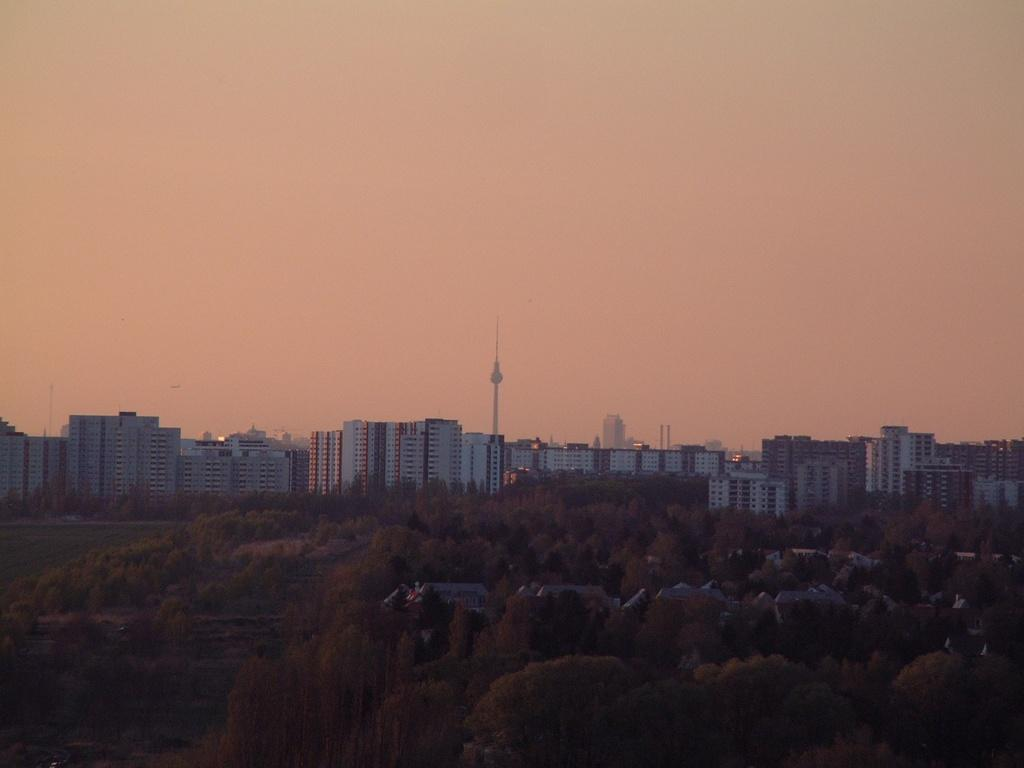What is located at the bottom of the picture? There are trees at the bottom of the picture. What can be seen in the background of the picture? There are trees, buildings, and a tower in the background. What is visible at the top of the picture? The sky is visible at the top of the picture. What type of spark can be seen coming from the lamp in the image? There is no lamp present in the image, so it is not possible to determine if there is a spark or not. 